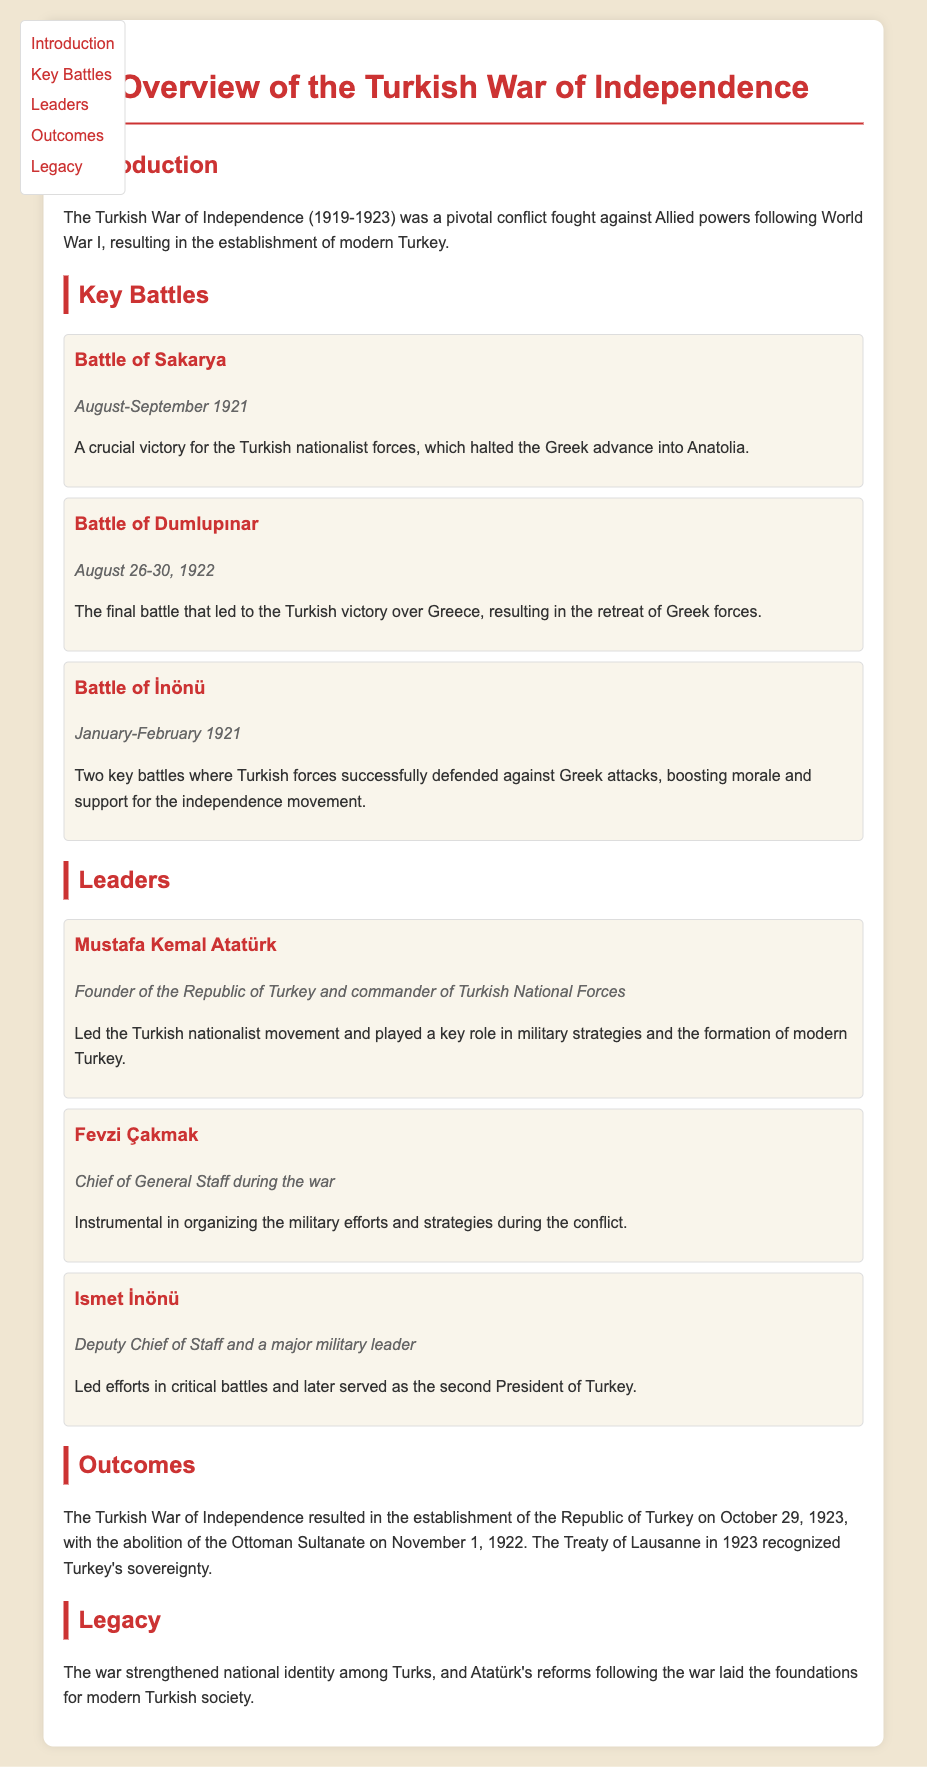What years did the Turkish War of Independence take place? The document states that the conflict was fought from 1919 to 1923.
Answer: 1919-1923 Which battle occurred in August-September 1921? The Battle of Sakarya is mentioned as taking place during this period.
Answer: Battle of Sakarya Who was the chief of General Staff during the war? The document identifies Fevzi Çakmak as the Chief of General Staff.
Answer: Fevzi Çakmak What was the outcome of the Battle of Dumlupınar? The document states it led to the Turkish victory and the retreat of Greek forces.
Answer: Turkish victory In what city was the Republic of Turkey established? The document does not specify a city but mentions the establishment of the Republic of Turkey.
Answer: Turkey Which leader is known as the founder of the Republic of Turkey? Mustafa Kemal Atatürk is recognized as the founder of the Republic.
Answer: Mustafa Kemal Atatürk What significant treaty recognized Turkey's sovereignty? The Treaty of Lausanne is mentioned in the document as the treaty that recognized Turkey's sovereignty.
Answer: Treaty of Lausanne What was a key impact of the Turkish War of Independence on national identity? The document states that the war strengthened national identity among Turks.
Answer: Strengthened national identity Which battle boosted morale and support for the independence movement? The document indicates that the Battle of İnönü played a role in boosting morale.
Answer: Battle of İnönü 